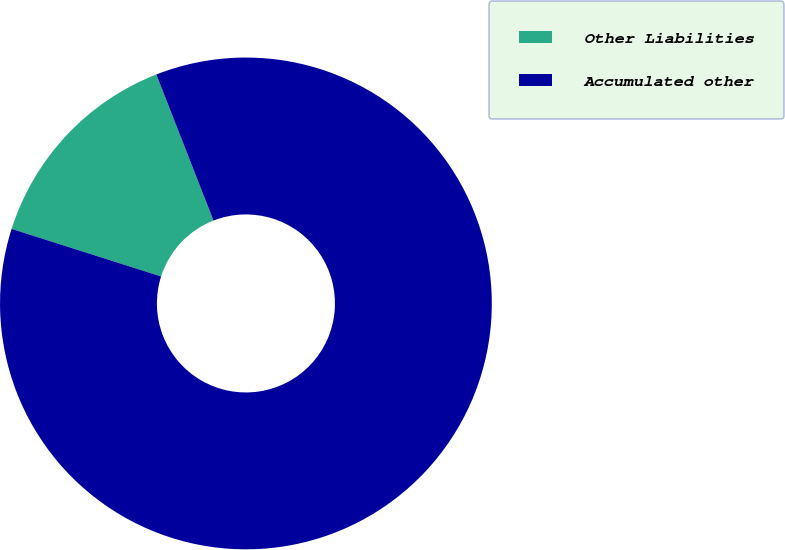Convert chart. <chart><loc_0><loc_0><loc_500><loc_500><pie_chart><fcel>Other Liabilities<fcel>Accumulated other<nl><fcel>14.16%<fcel>85.84%<nl></chart> 